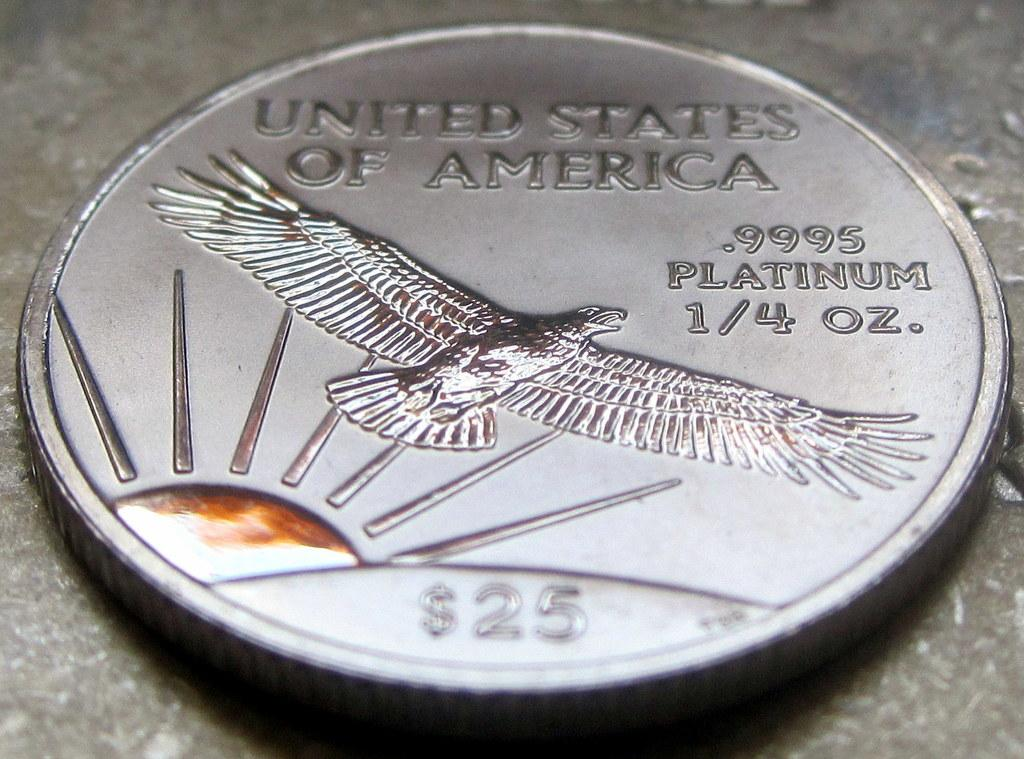<image>
Describe the image concisely. A silver coin from the United States of America is made from .9995 Platinum 1.4 oz and is worth $25 